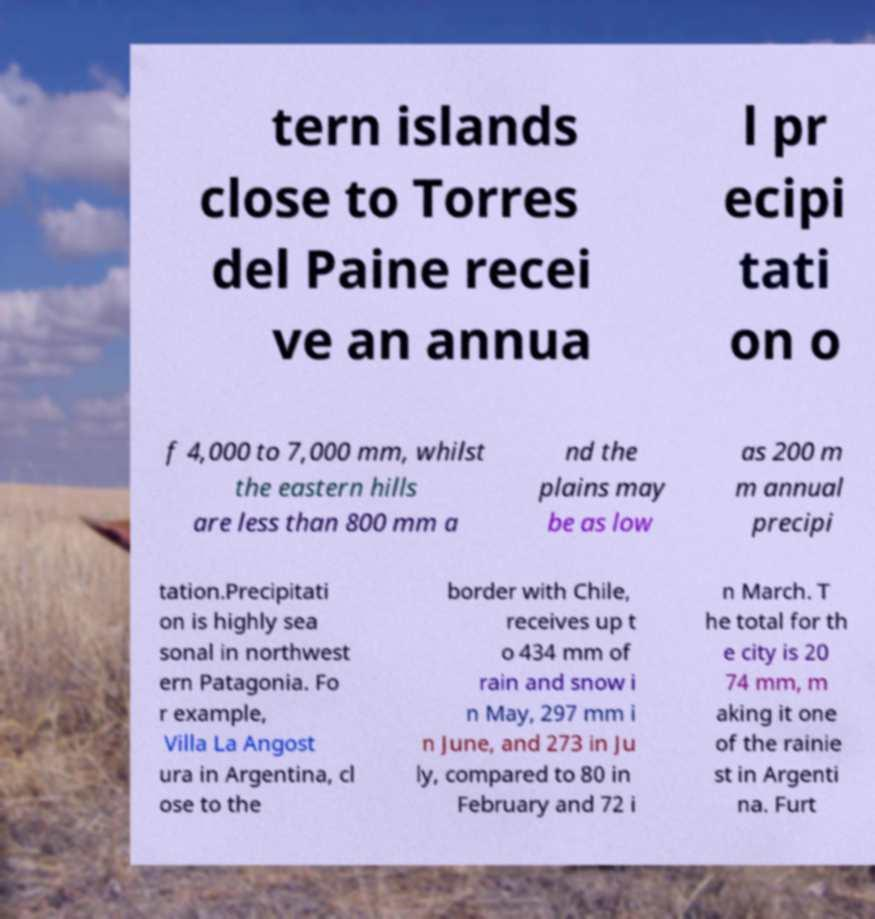I need the written content from this picture converted into text. Can you do that? tern islands close to Torres del Paine recei ve an annua l pr ecipi tati on o f 4,000 to 7,000 mm, whilst the eastern hills are less than 800 mm a nd the plains may be as low as 200 m m annual precipi tation.Precipitati on is highly sea sonal in northwest ern Patagonia. Fo r example, Villa La Angost ura in Argentina, cl ose to the border with Chile, receives up t o 434 mm of rain and snow i n May, 297 mm i n June, and 273 in Ju ly, compared to 80 in February and 72 i n March. T he total for th e city is 20 74 mm, m aking it one of the rainie st in Argenti na. Furt 